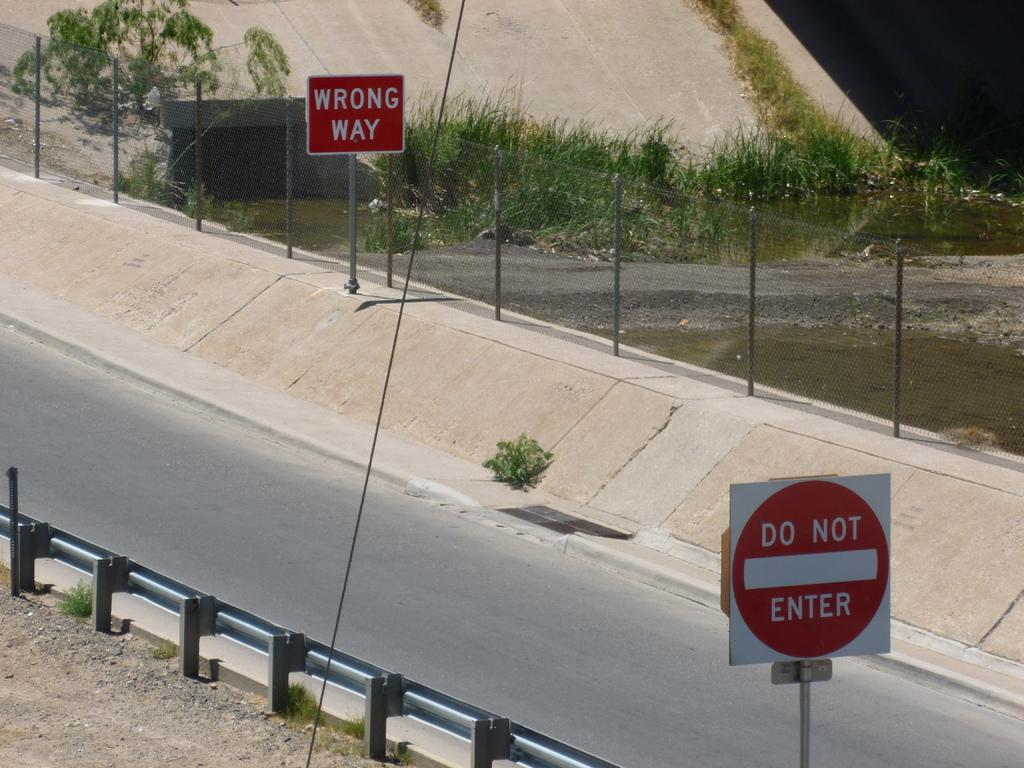<image>
Share a concise interpretation of the image provided. A wrong way sign and a do not enter sign sit on a side street. 